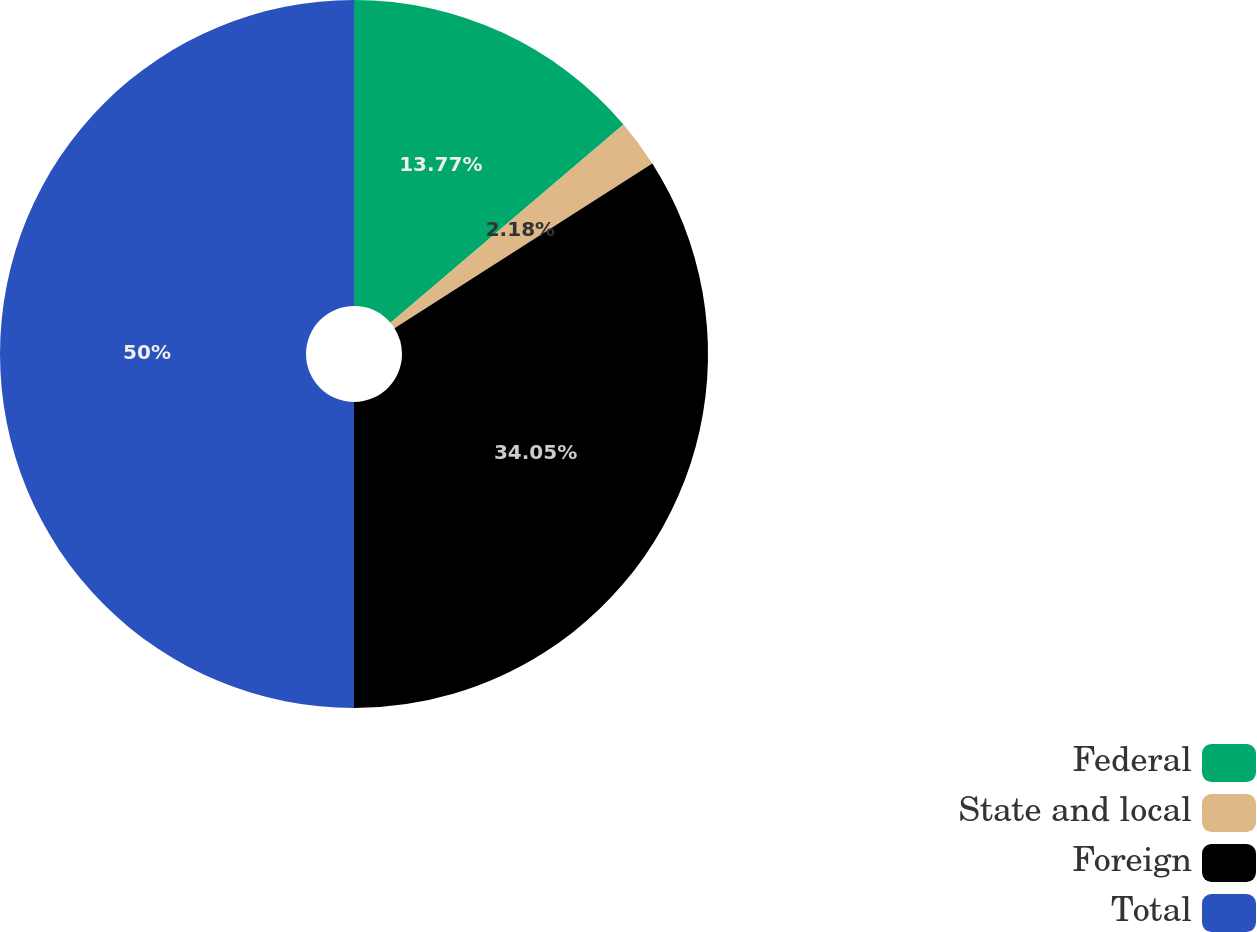Convert chart. <chart><loc_0><loc_0><loc_500><loc_500><pie_chart><fcel>Federal<fcel>State and local<fcel>Foreign<fcel>Total<nl><fcel>13.77%<fcel>2.18%<fcel>34.05%<fcel>50.0%<nl></chart> 